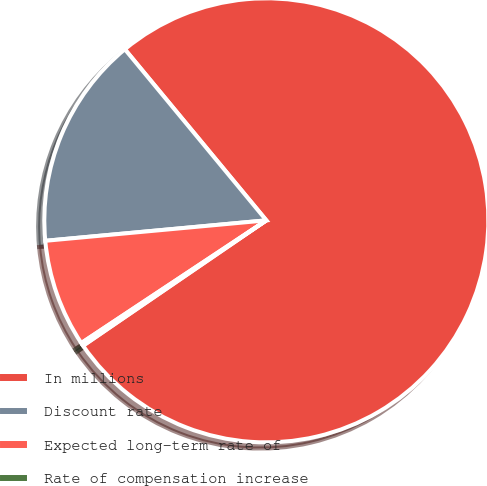Convert chart. <chart><loc_0><loc_0><loc_500><loc_500><pie_chart><fcel>In millions<fcel>Discount rate<fcel>Expected long-term rate of<fcel>Rate of compensation increase<nl><fcel>76.45%<fcel>15.47%<fcel>7.85%<fcel>0.23%<nl></chart> 